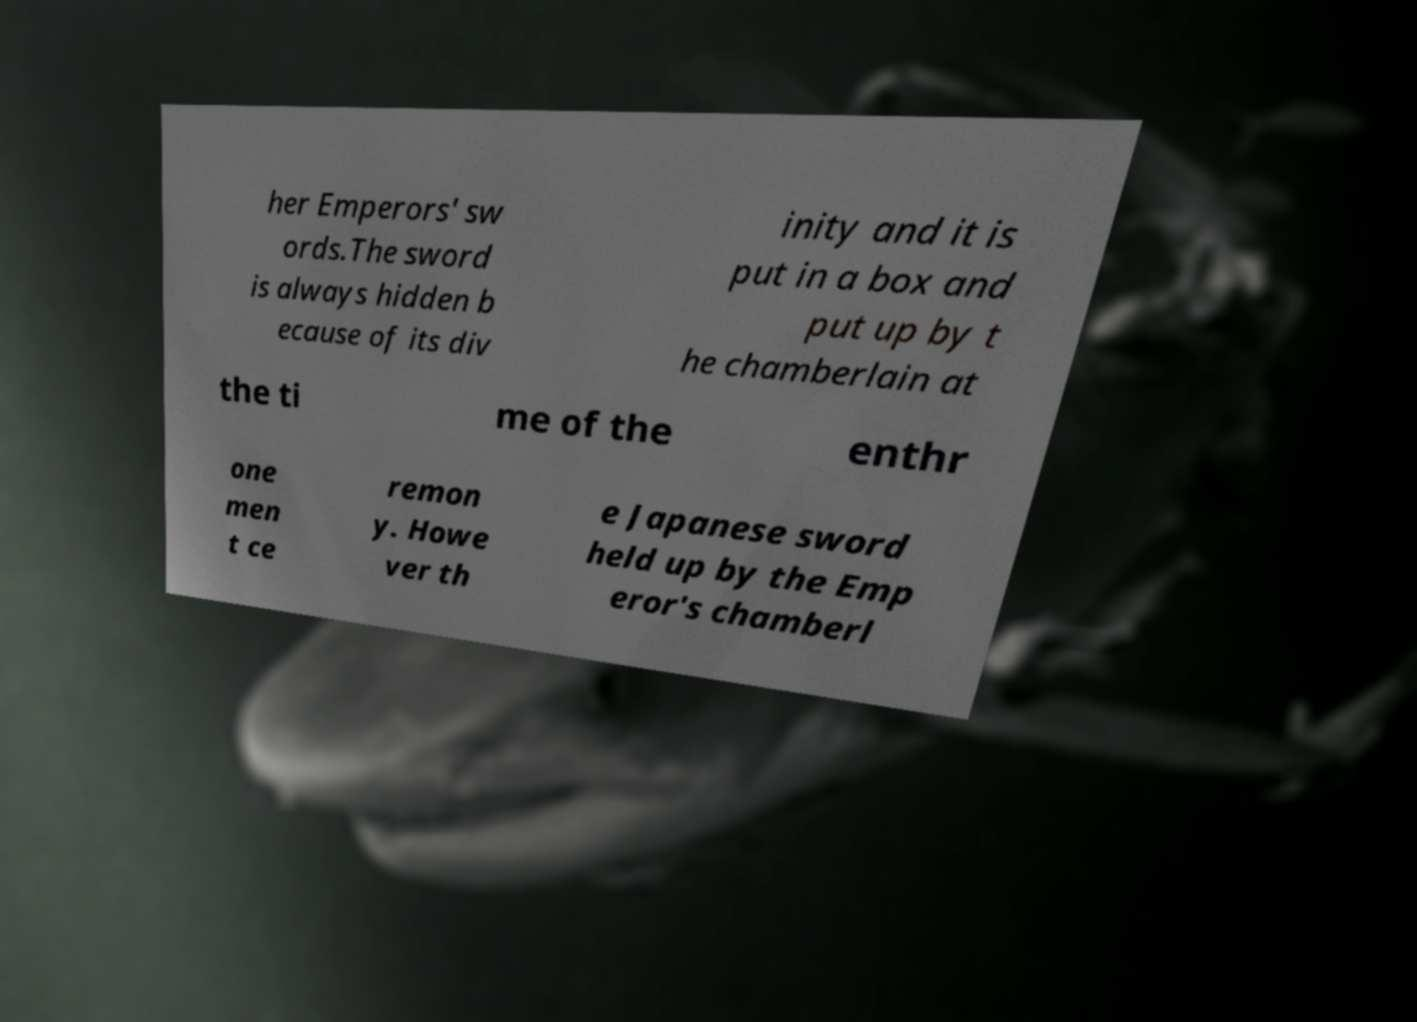There's text embedded in this image that I need extracted. Can you transcribe it verbatim? her Emperors' sw ords.The sword is always hidden b ecause of its div inity and it is put in a box and put up by t he chamberlain at the ti me of the enthr one men t ce remon y. Howe ver th e Japanese sword held up by the Emp eror's chamberl 